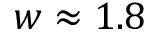Convert formula to latex. <formula><loc_0><loc_0><loc_500><loc_500>w \approx 1 . 8</formula> 